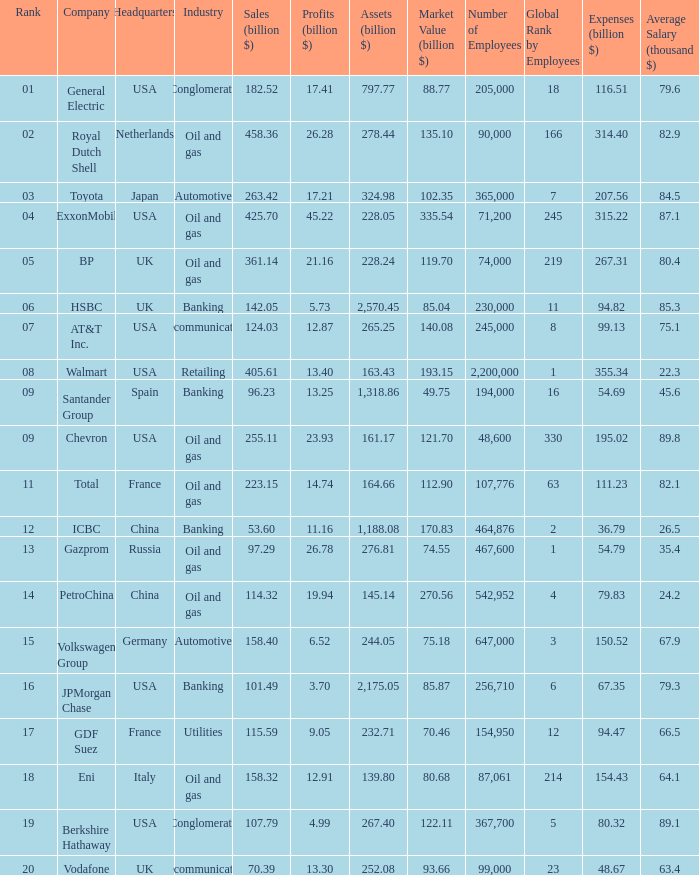Name the Sales (billion $) which have a Company of exxonmobil? 425.7. 